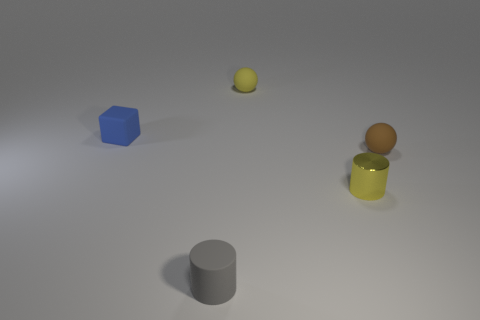Add 5 rubber spheres. How many objects exist? 10 Subtract all cylinders. How many objects are left? 3 Subtract all tiny yellow balls. Subtract all tiny shiny objects. How many objects are left? 3 Add 5 small spheres. How many small spheres are left? 7 Add 2 small shiny things. How many small shiny things exist? 3 Subtract 1 gray cylinders. How many objects are left? 4 